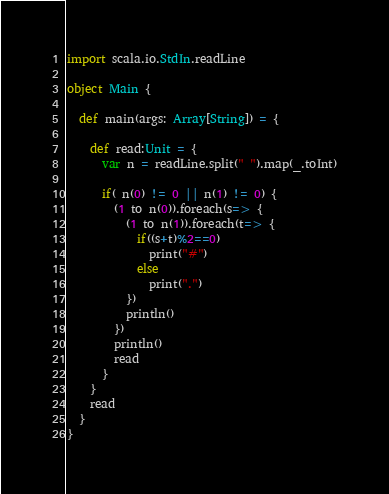<code> <loc_0><loc_0><loc_500><loc_500><_Scala_>import scala.io.StdIn.readLine

object Main {

  def main(args: Array[String]) = {

    def read:Unit = {
      var n = readLine.split(" ").map(_.toInt)

      if( n(0) != 0 || n(1) != 0) {
        (1 to n(0)).foreach(s=> {
          (1 to n(1)).foreach(t=> {
            if((s+t)%2==0)
              print("#")
            else
              print(".")
          })
          println()
        })
        println()
        read
      }
    }
    read
  }
}</code> 